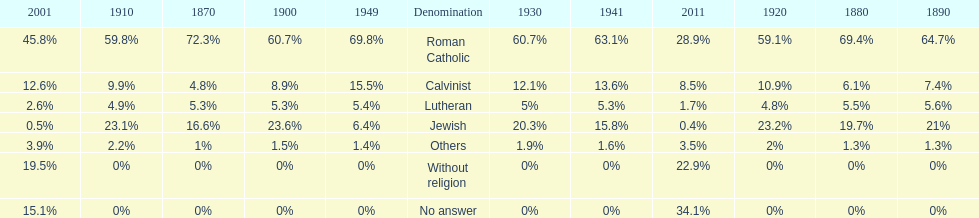Which religious denomination had a higher percentage in 1900, jewish or roman catholic? Roman Catholic. 